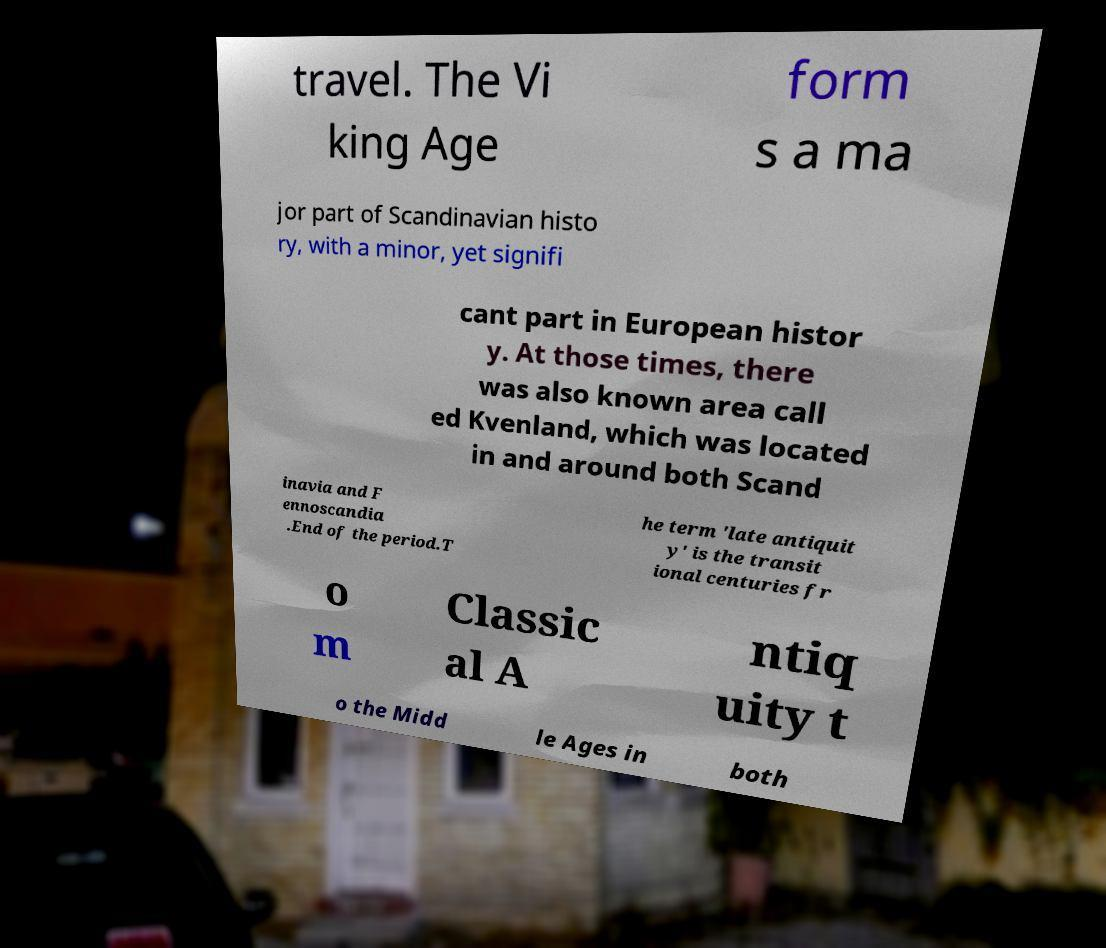Can you accurately transcribe the text from the provided image for me? travel. The Vi king Age form s a ma jor part of Scandinavian histo ry, with a minor, yet signifi cant part in European histor y. At those times, there was also known area call ed Kvenland, which was located in and around both Scand inavia and F ennoscandia .End of the period.T he term 'late antiquit y' is the transit ional centuries fr o m Classic al A ntiq uity t o the Midd le Ages in both 